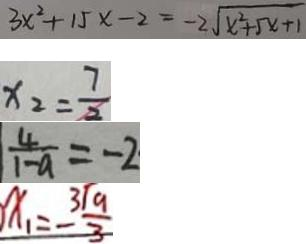Convert formula to latex. <formula><loc_0><loc_0><loc_500><loc_500>3 x ^ { 2 } + 1 5 x - 2 = - 2 \sqrt { x ^ { 2 } + 5 x + 1 } 
 x _ { 2 } = \frac { 7 } { 2 } 
 \frac { 4 } { 1 - a } = - 2 
 x _ { 1 } = \frac { 3 \sqrt { 9 } } { 3 }</formula> 